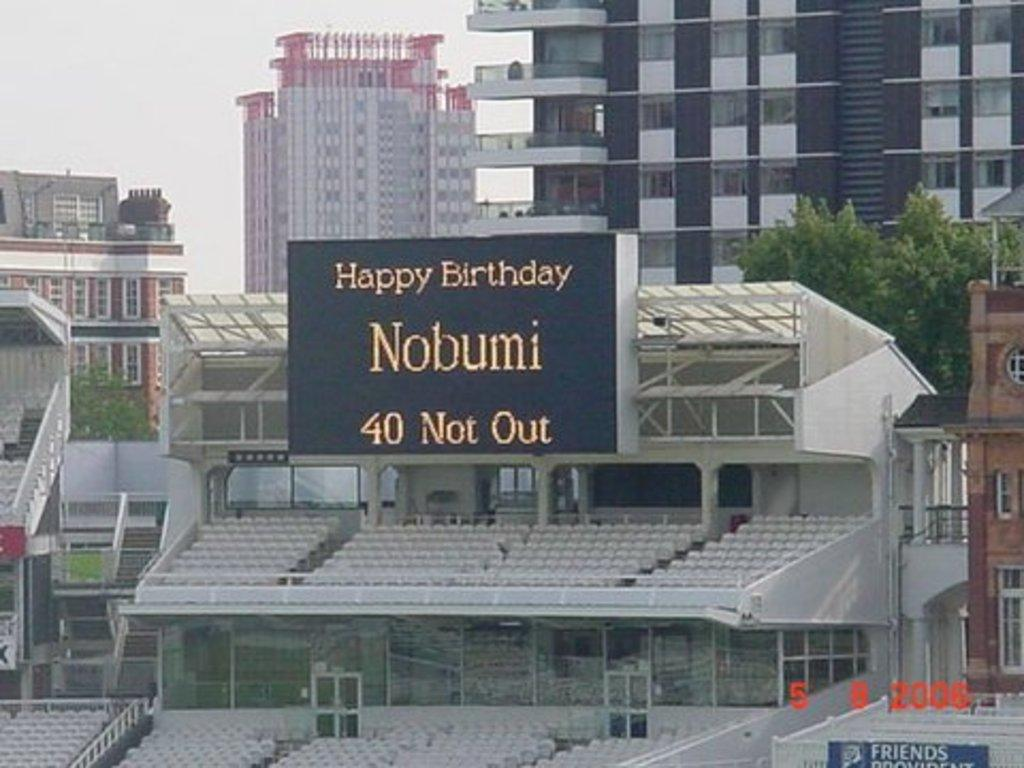<image>
Share a concise interpretation of the image provided. a sign with the word Nobumi on it 